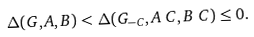Convert formula to latex. <formula><loc_0><loc_0><loc_500><loc_500>\Delta ( G , A , B ) & < \Delta ( G _ { - C } , A \ C , B \ C ) \leq 0 .</formula> 